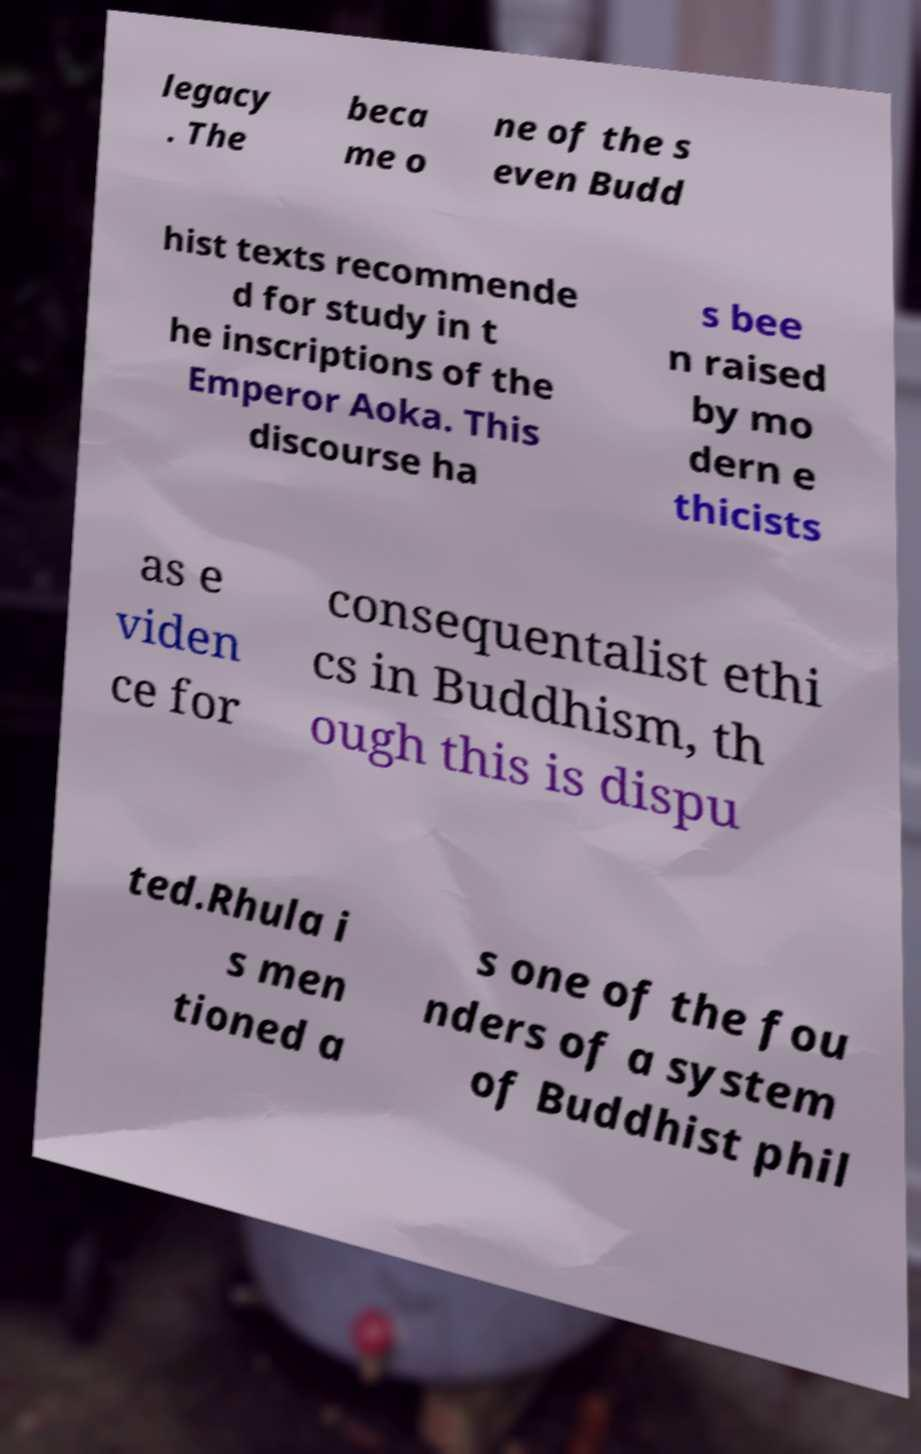For documentation purposes, I need the text within this image transcribed. Could you provide that? legacy . The beca me o ne of the s even Budd hist texts recommende d for study in t he inscriptions of the Emperor Aoka. This discourse ha s bee n raised by mo dern e thicists as e viden ce for consequentalist ethi cs in Buddhism, th ough this is dispu ted.Rhula i s men tioned a s one of the fou nders of a system of Buddhist phil 